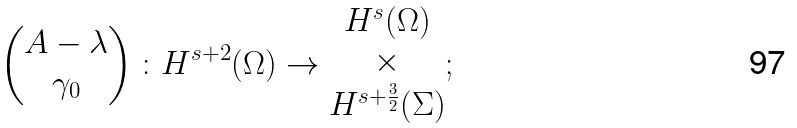<formula> <loc_0><loc_0><loc_500><loc_500>\begin{pmatrix} A - \lambda \\ \gamma _ { 0 } \end{pmatrix} \colon H ^ { s + 2 } ( \Omega ) \to \begin{matrix} H ^ { s } ( \Omega ) \\ \times \\ { H } ^ { s + \frac { 3 } { 2 } } ( \Sigma ) \end{matrix} ;</formula> 